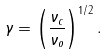Convert formula to latex. <formula><loc_0><loc_0><loc_500><loc_500>\gamma = \left ( \frac { \nu _ { c } } { \nu _ { o } } \right ) ^ { 1 / 2 } .</formula> 